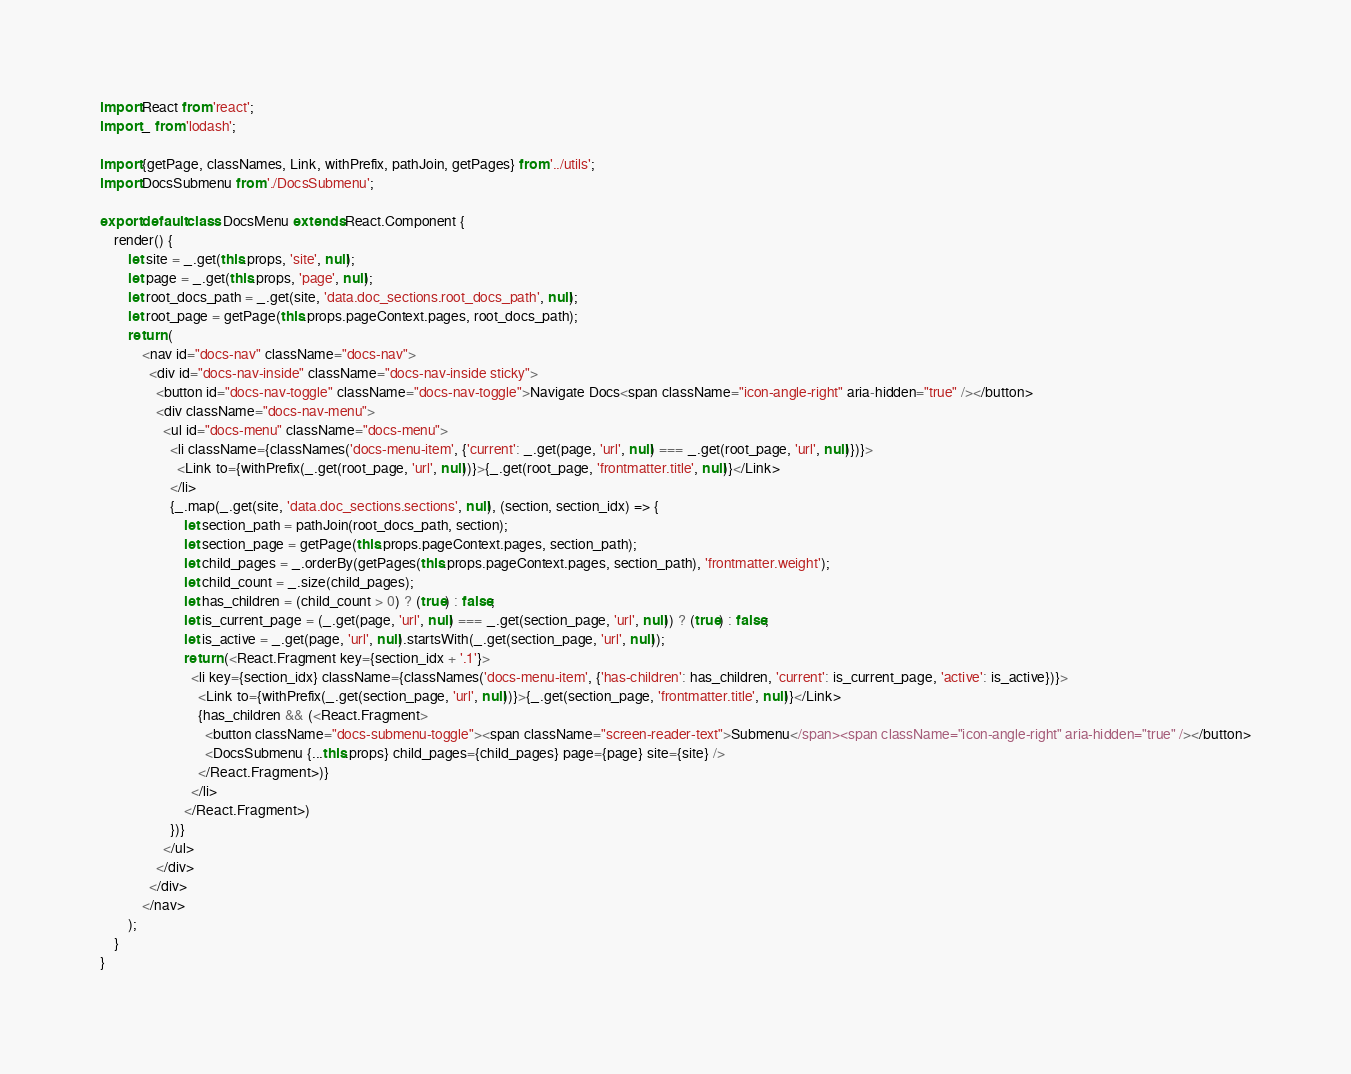Convert code to text. <code><loc_0><loc_0><loc_500><loc_500><_JavaScript_>import React from 'react';
import _ from 'lodash';

import {getPage, classNames, Link, withPrefix, pathJoin, getPages} from '../utils';
import DocsSubmenu from './DocsSubmenu';

export default class DocsMenu extends React.Component {
    render() {
        let site = _.get(this.props, 'site', null);
        let page = _.get(this.props, 'page', null);
        let root_docs_path = _.get(site, 'data.doc_sections.root_docs_path', null);
        let root_page = getPage(this.props.pageContext.pages, root_docs_path);
        return (
            <nav id="docs-nav" className="docs-nav">
              <div id="docs-nav-inside" className="docs-nav-inside sticky">
                <button id="docs-nav-toggle" className="docs-nav-toggle">Navigate Docs<span className="icon-angle-right" aria-hidden="true" /></button>
                <div className="docs-nav-menu">
                  <ul id="docs-menu" className="docs-menu">
                    <li className={classNames('docs-menu-item', {'current': _.get(page, 'url', null) === _.get(root_page, 'url', null)})}>
                      <Link to={withPrefix(_.get(root_page, 'url', null))}>{_.get(root_page, 'frontmatter.title', null)}</Link>
                    </li>
                    {_.map(_.get(site, 'data.doc_sections.sections', null), (section, section_idx) => {
                        let section_path = pathJoin(root_docs_path, section);
                        let section_page = getPage(this.props.pageContext.pages, section_path);
                        let child_pages = _.orderBy(getPages(this.props.pageContext.pages, section_path), 'frontmatter.weight');
                        let child_count = _.size(child_pages);
                        let has_children = (child_count > 0) ? (true) : false;
                        let is_current_page = (_.get(page, 'url', null) === _.get(section_page, 'url', null)) ? (true) : false;
                        let is_active = _.get(page, 'url', null).startsWith(_.get(section_page, 'url', null));
                        return (<React.Fragment key={section_idx + '.1'}>
                          <li key={section_idx} className={classNames('docs-menu-item', {'has-children': has_children, 'current': is_current_page, 'active': is_active})}>
                            <Link to={withPrefix(_.get(section_page, 'url', null))}>{_.get(section_page, 'frontmatter.title', null)}</Link>
                            {has_children && (<React.Fragment>
                              <button className="docs-submenu-toggle"><span className="screen-reader-text">Submenu</span><span className="icon-angle-right" aria-hidden="true" /></button>
                              <DocsSubmenu {...this.props} child_pages={child_pages} page={page} site={site} />
                            </React.Fragment>)}
                          </li>
                        </React.Fragment>)
                    })}
                  </ul>
                </div>
              </div>
            </nav>
        );
    }
}
</code> 